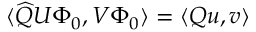Convert formula to latex. <formula><loc_0><loc_0><loc_500><loc_500>\langle \widehat { Q } U \Phi _ { 0 } , V \Phi _ { 0 } \rangle = \langle Q u , v \rangle</formula> 